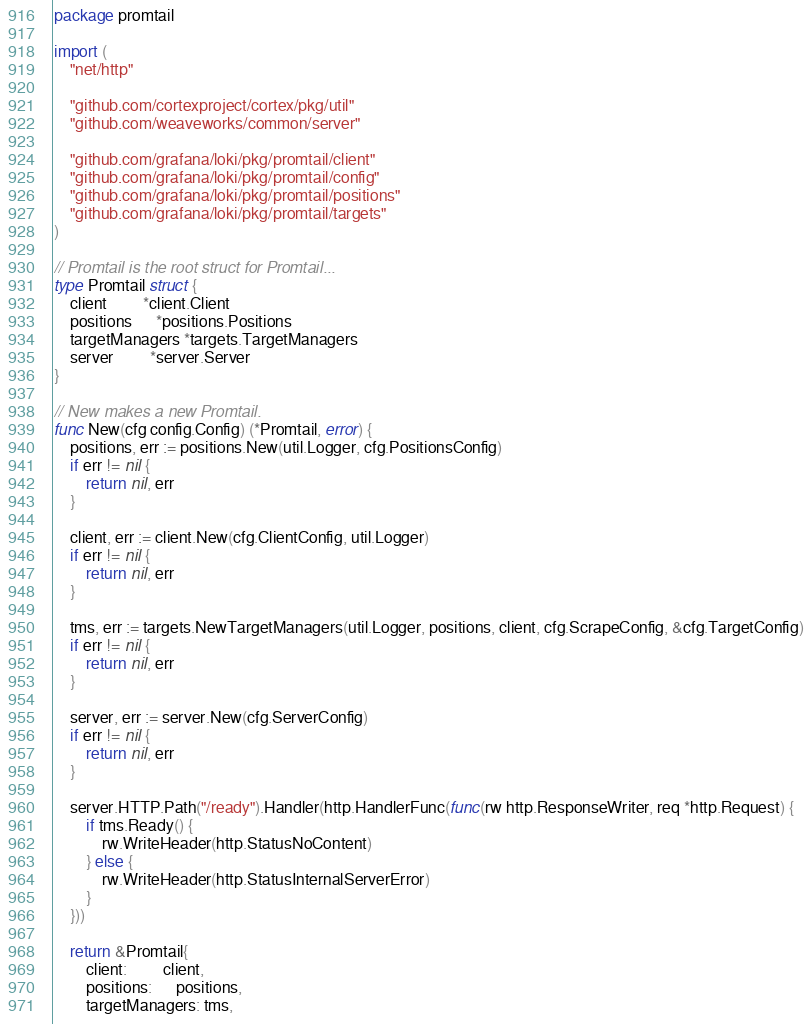Convert code to text. <code><loc_0><loc_0><loc_500><loc_500><_Go_>package promtail

import (
	"net/http"

	"github.com/cortexproject/cortex/pkg/util"
	"github.com/weaveworks/common/server"

	"github.com/grafana/loki/pkg/promtail/client"
	"github.com/grafana/loki/pkg/promtail/config"
	"github.com/grafana/loki/pkg/promtail/positions"
	"github.com/grafana/loki/pkg/promtail/targets"
)

// Promtail is the root struct for Promtail...
type Promtail struct {
	client         *client.Client
	positions      *positions.Positions
	targetManagers *targets.TargetManagers
	server         *server.Server
}

// New makes a new Promtail.
func New(cfg config.Config) (*Promtail, error) {
	positions, err := positions.New(util.Logger, cfg.PositionsConfig)
	if err != nil {
		return nil, err
	}

	client, err := client.New(cfg.ClientConfig, util.Logger)
	if err != nil {
		return nil, err
	}

	tms, err := targets.NewTargetManagers(util.Logger, positions, client, cfg.ScrapeConfig, &cfg.TargetConfig)
	if err != nil {
		return nil, err
	}

	server, err := server.New(cfg.ServerConfig)
	if err != nil {
		return nil, err
	}

	server.HTTP.Path("/ready").Handler(http.HandlerFunc(func(rw http.ResponseWriter, req *http.Request) {
		if tms.Ready() {
			rw.WriteHeader(http.StatusNoContent)
		} else {
			rw.WriteHeader(http.StatusInternalServerError)
		}
	}))

	return &Promtail{
		client:         client,
		positions:      positions,
		targetManagers: tms,</code> 